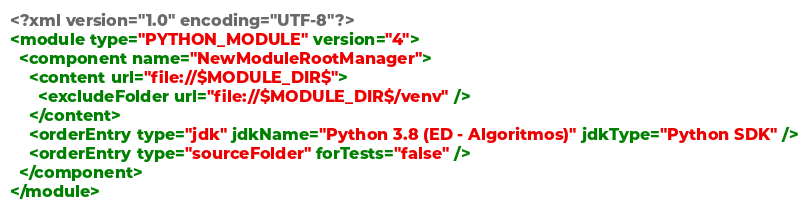<code> <loc_0><loc_0><loc_500><loc_500><_XML_><?xml version="1.0" encoding="UTF-8"?>
<module type="PYTHON_MODULE" version="4">
  <component name="NewModuleRootManager">
    <content url="file://$MODULE_DIR$">
      <excludeFolder url="file://$MODULE_DIR$/venv" />
    </content>
    <orderEntry type="jdk" jdkName="Python 3.8 (ED - Algoritmos)" jdkType="Python SDK" />
    <orderEntry type="sourceFolder" forTests="false" />
  </component>
</module></code> 